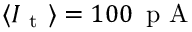<formula> <loc_0><loc_0><loc_500><loc_500>\langle I _ { t } \rangle = 1 0 0 \, p A</formula> 